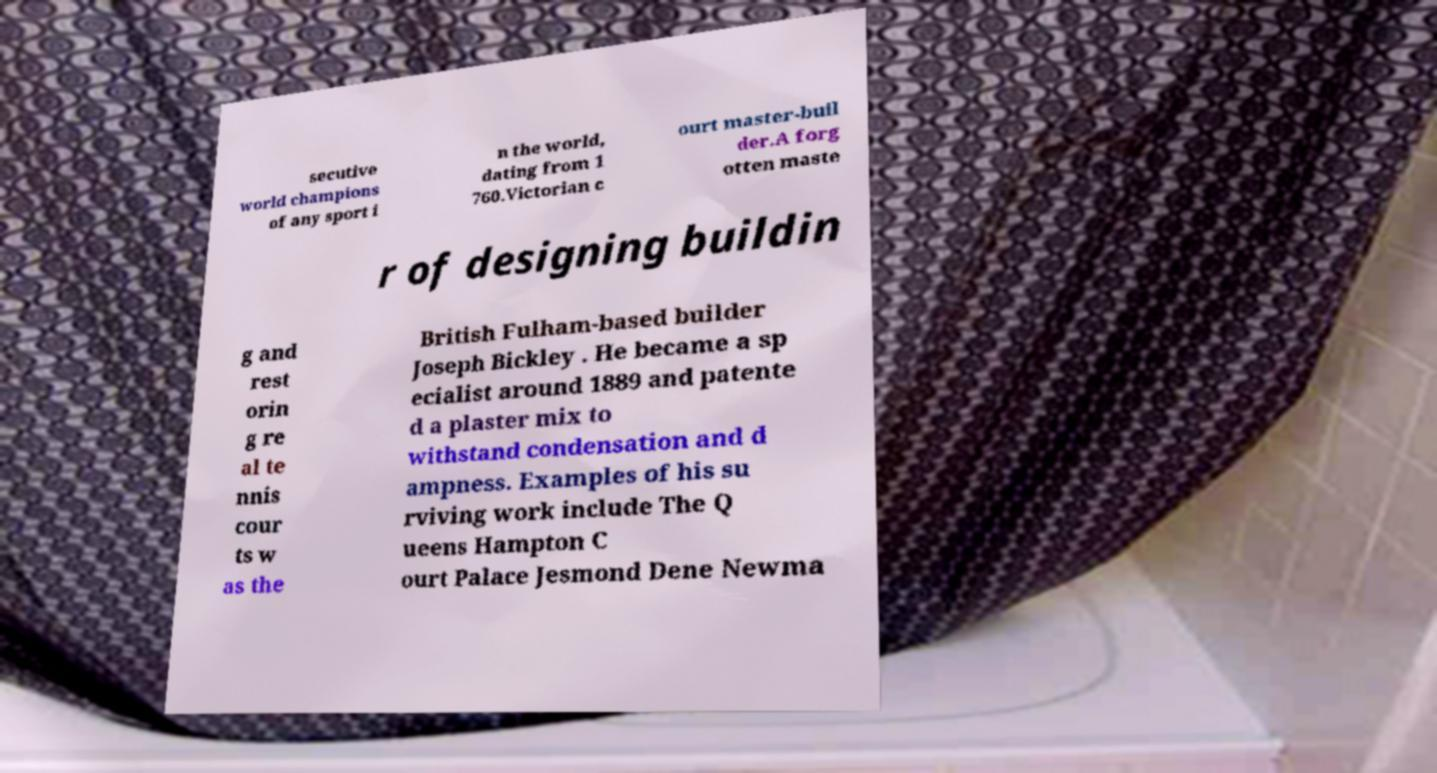Can you accurately transcribe the text from the provided image for me? secutive world champions of any sport i n the world, dating from 1 760.Victorian c ourt master-buil der.A forg otten maste r of designing buildin g and rest orin g re al te nnis cour ts w as the British Fulham-based builder Joseph Bickley . He became a sp ecialist around 1889 and patente d a plaster mix to withstand condensation and d ampness. Examples of his su rviving work include The Q ueens Hampton C ourt Palace Jesmond Dene Newma 